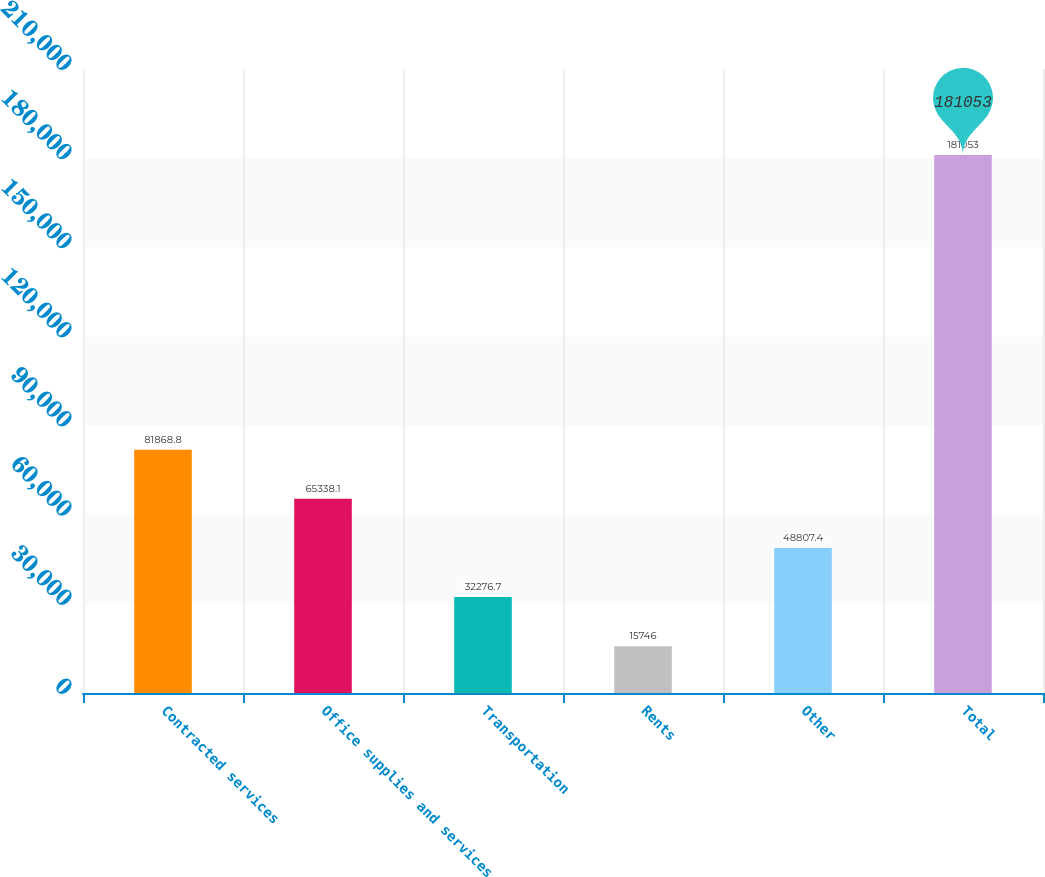Convert chart to OTSL. <chart><loc_0><loc_0><loc_500><loc_500><bar_chart><fcel>Contracted services<fcel>Office supplies and services<fcel>Transportation<fcel>Rents<fcel>Other<fcel>Total<nl><fcel>81868.8<fcel>65338.1<fcel>32276.7<fcel>15746<fcel>48807.4<fcel>181053<nl></chart> 